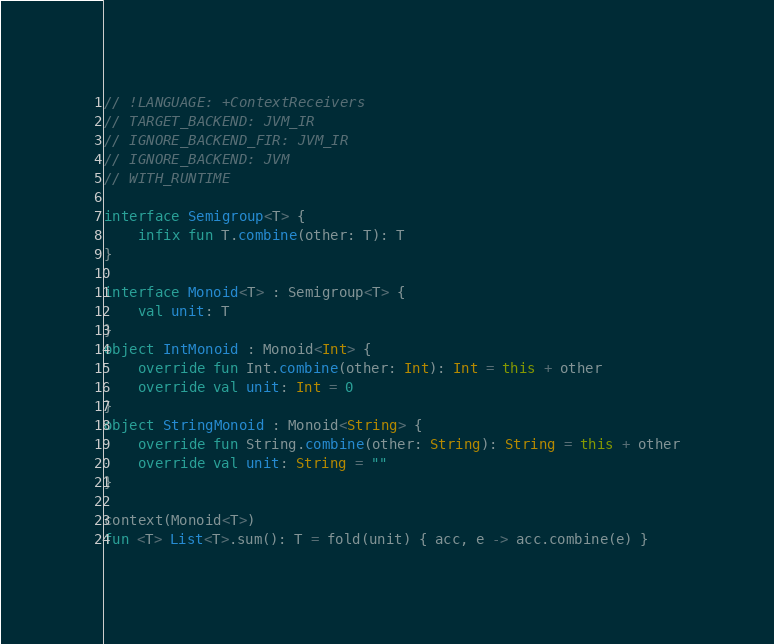<code> <loc_0><loc_0><loc_500><loc_500><_Kotlin_>// !LANGUAGE: +ContextReceivers
// TARGET_BACKEND: JVM_IR
// IGNORE_BACKEND_FIR: JVM_IR
// IGNORE_BACKEND: JVM
// WITH_RUNTIME

interface Semigroup<T> {
    infix fun T.combine(other: T): T
}

interface Monoid<T> : Semigroup<T> {
    val unit: T
}
object IntMonoid : Monoid<Int> {
    override fun Int.combine(other: Int): Int = this + other
    override val unit: Int = 0
}
object StringMonoid : Monoid<String> {
    override fun String.combine(other: String): String = this + other
    override val unit: String = ""
}

context(Monoid<T>)
fun <T> List<T>.sum(): T = fold(unit) { acc, e -> acc.combine(e) }</code> 